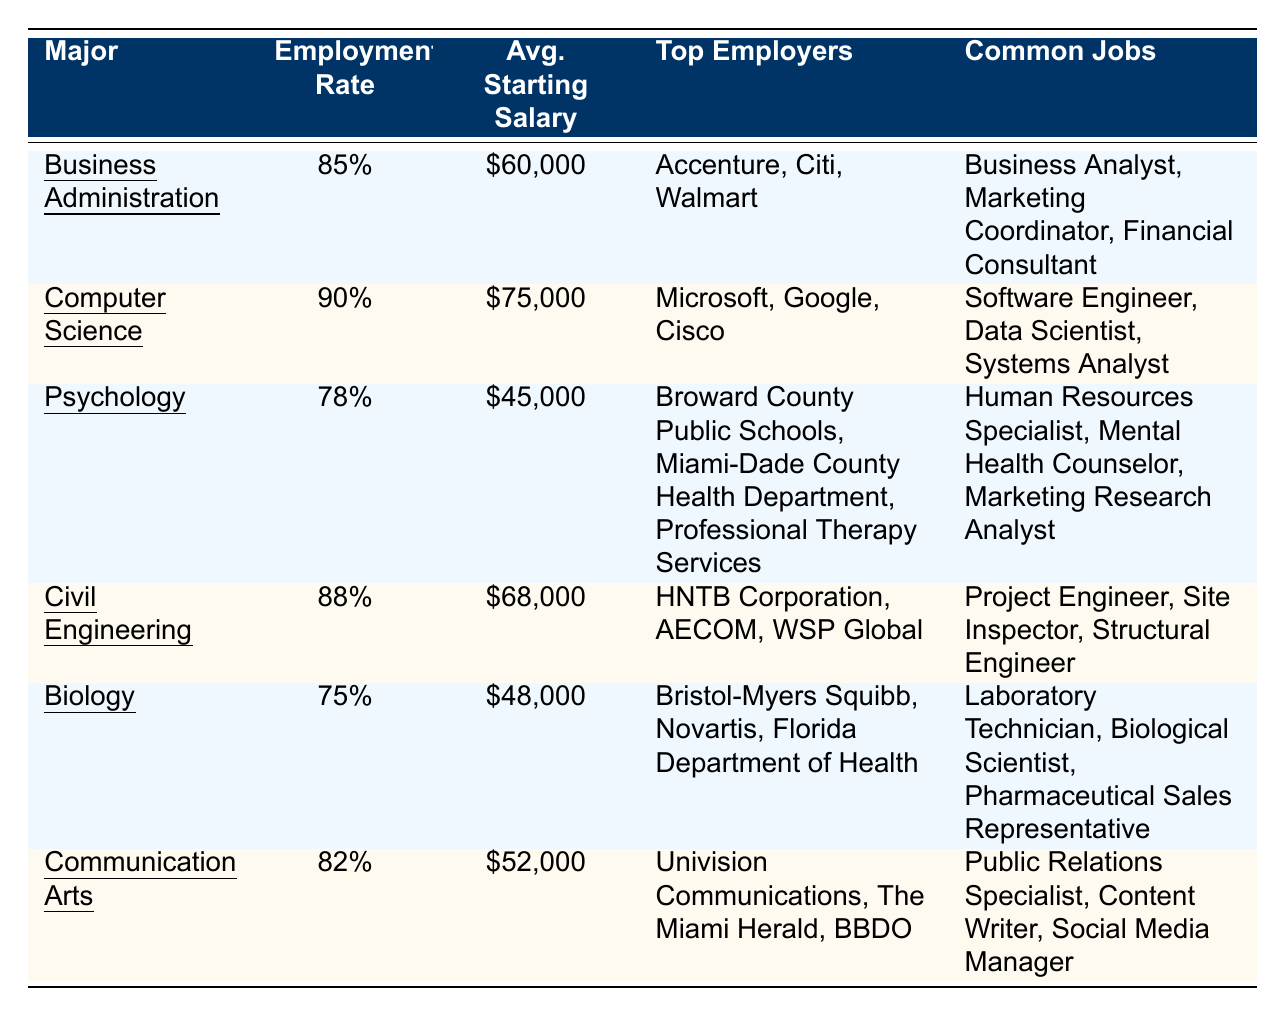What is the average starting salary for graduates in Computer Science? The average starting salary for Computer Science graduates is listed in the table as $75,000.
Answer: $75,000 What is the employment rate for Psychology majors? The employment rate for Psychology majors is found in the table under that major, listed as 78%.
Answer: 78% Which major has the highest employment rate? Looking through the listed employment rates, Computer Science has the highest rate at 90%.
Answer: Computer Science What are the common jobs for graduates in Civil Engineering? The table lists the common jobs for Civil Engineering as Project Engineer, Site Inspector, and Structural Engineer.
Answer: Project Engineer, Site Inspector, Structural Engineer Which major has the lowest average starting salary? Checking the average starting salaries, Biology has the lowest at $48,000.
Answer: Biology Is the employment rate for Communication Arts higher than that for Psychology? Comparing the two rates, Communication Arts has an 82% employment rate while Psychology has 78%, confirming that Communication Arts is higher.
Answer: Yes What is the difference in average starting salary between Business Administration and Psychology? The average starting salary for Business Administration is $60,000, and for Psychology, it is $45,000. The difference is $60,000 - $45,000 = $15,000.
Answer: $15,000 List the top employers for Biology graduates. The top employers for Biology graduates include Bristol-Myers Squibb, Novartis, and the Florida Department of Health.
Answer: Bristol-Myers Squibb, Novartis, Florida Department of Health What percentage of Civil Engineering graduates are employed? The table shows that 88% of Civil Engineering graduates are employed.
Answer: 88% Which major has top employers including Accenture and Walmart? The major with top employers including Accenture and Walmart is Business Administration.
Answer: Business Administration If the average starting salary of Psychology is $45,000 and for Computer Science is $75,000, what is their average? The average starting salary is calculated by adding both salaries ($45,000 + $75,000 = $120,000) and dividing by 2, resulting in $120,000 / 2 = $60,000.
Answer: $60,000 